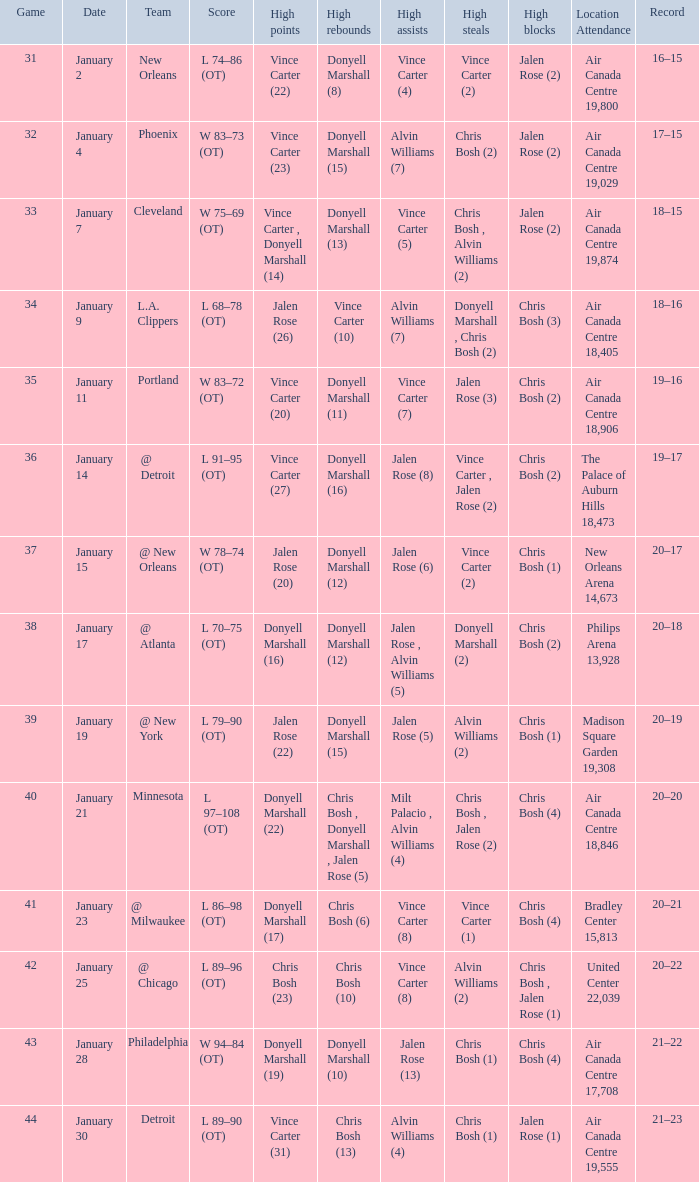What is the Location and Attendance with a Record of 21–22? Air Canada Centre 17,708. 